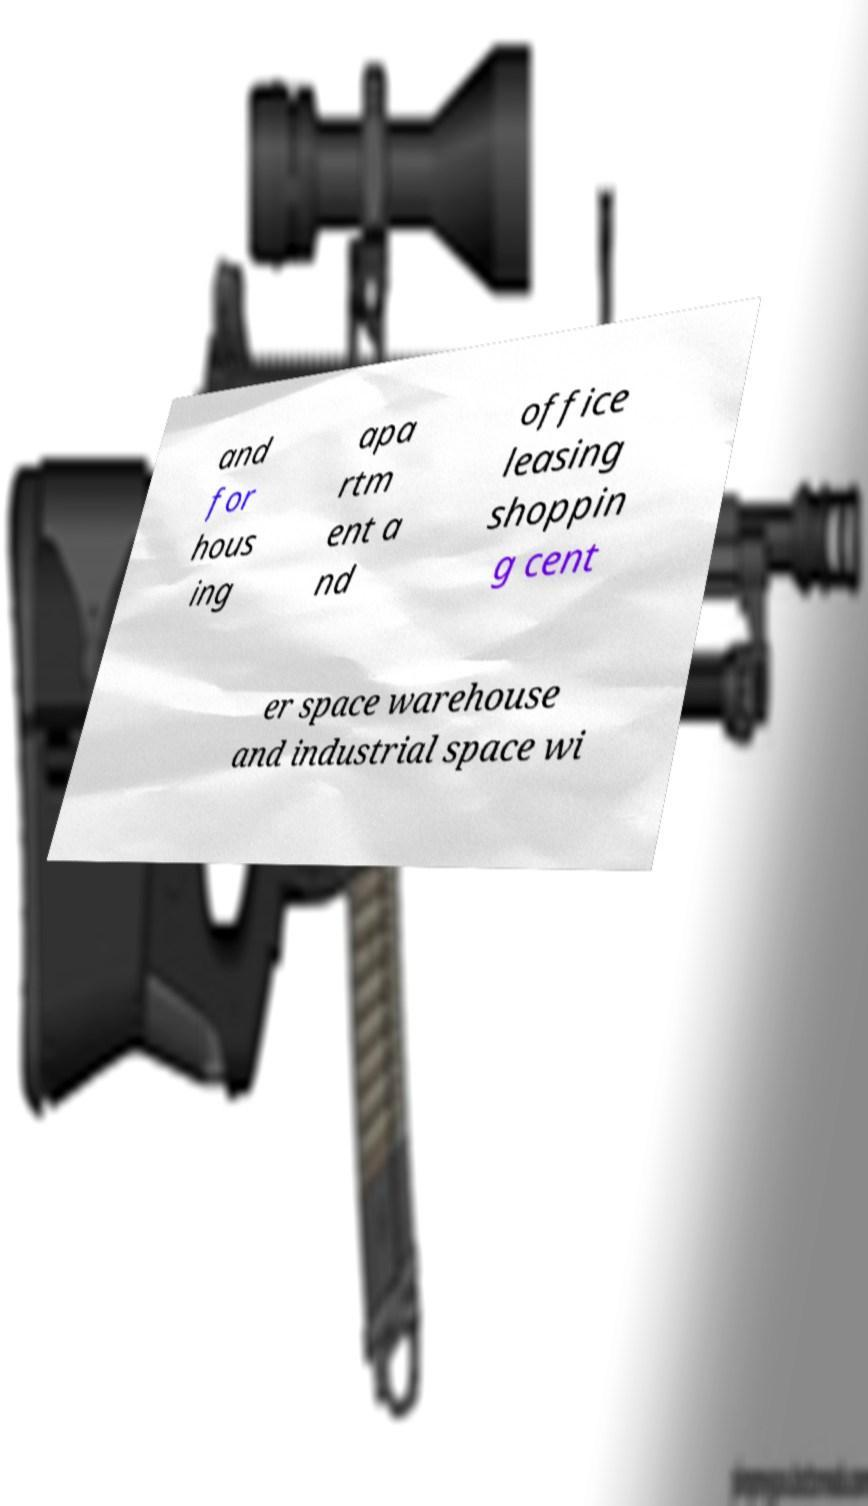Please identify and transcribe the text found in this image. and for hous ing apa rtm ent a nd office leasing shoppin g cent er space warehouse and industrial space wi 